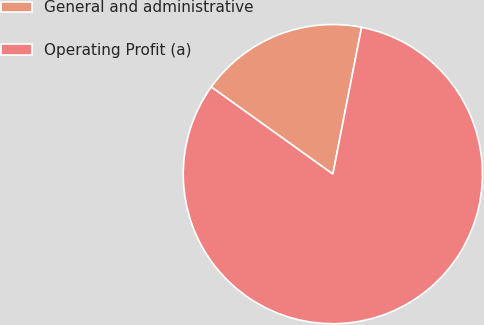Convert chart. <chart><loc_0><loc_0><loc_500><loc_500><pie_chart><fcel>General and administrative<fcel>Operating Profit (a)<nl><fcel>18.18%<fcel>81.82%<nl></chart> 